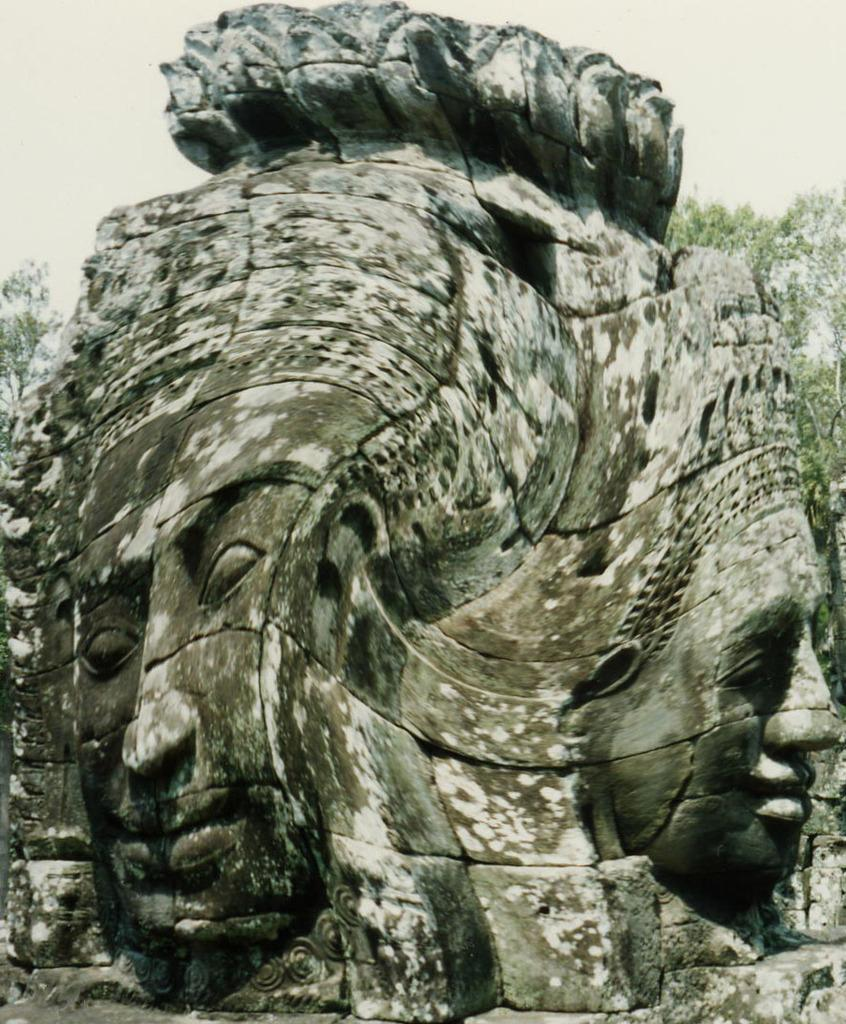What is depicted on the huge rock in the image? There are carvings of humans on a huge rock in the image. What can be seen in the background of the image? There are trees visible in the background of the image. What is visible in the sky in the image? The sky is visible in the image. How many servants are present in the image? There is no mention of servants in the image; it features carvings of humans on a huge rock, trees in the background, and the sky. 